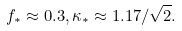Convert formula to latex. <formula><loc_0><loc_0><loc_500><loc_500>f _ { * } \approx 0 . 3 , \kappa _ { * } \approx 1 . 1 7 / \sqrt { 2 } .</formula> 